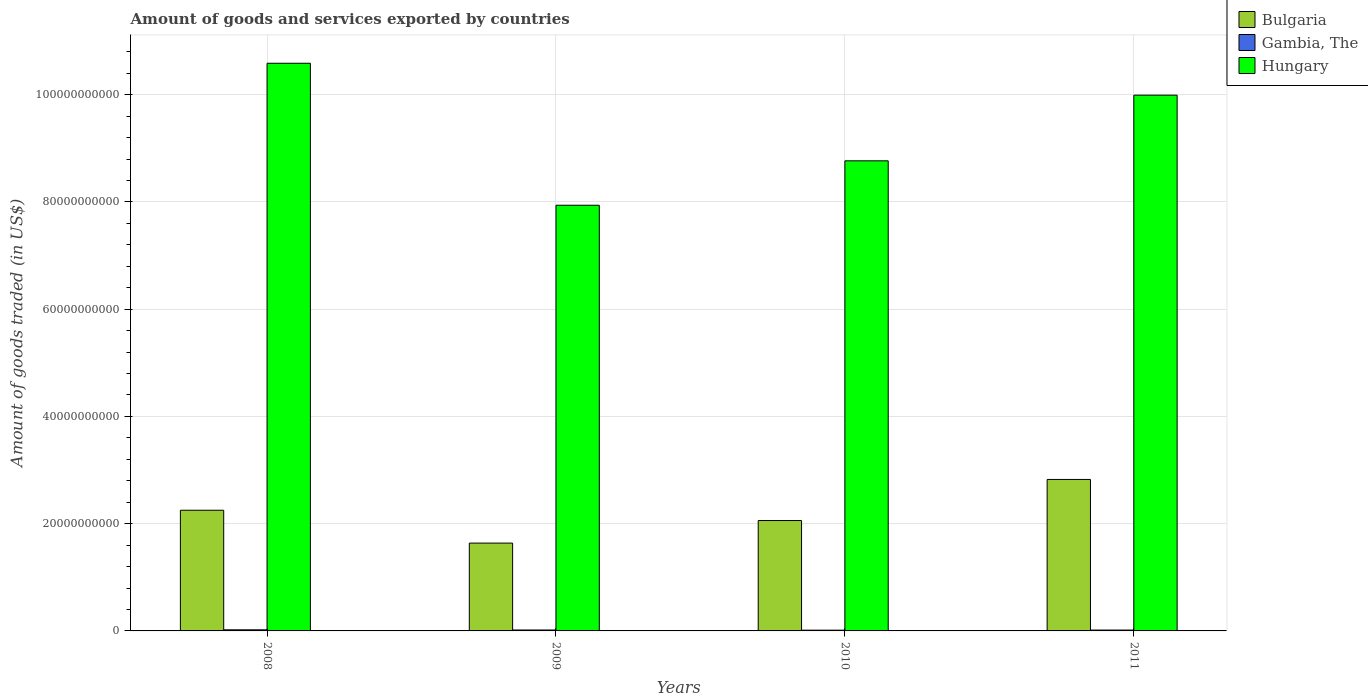How many different coloured bars are there?
Your response must be concise. 3. How many bars are there on the 4th tick from the right?
Offer a very short reply. 3. In how many cases, is the number of bars for a given year not equal to the number of legend labels?
Provide a succinct answer. 0. What is the total amount of goods and services exported in Bulgaria in 2010?
Offer a very short reply. 2.06e+1. Across all years, what is the maximum total amount of goods and services exported in Bulgaria?
Offer a very short reply. 2.82e+1. Across all years, what is the minimum total amount of goods and services exported in Hungary?
Your response must be concise. 7.94e+1. In which year was the total amount of goods and services exported in Hungary maximum?
Your answer should be very brief. 2008. What is the total total amount of goods and services exported in Gambia, The in the graph?
Ensure brevity in your answer.  6.82e+08. What is the difference between the total amount of goods and services exported in Bulgaria in 2010 and that in 2011?
Your answer should be compact. -7.66e+09. What is the difference between the total amount of goods and services exported in Hungary in 2008 and the total amount of goods and services exported in Gambia, The in 2010?
Keep it short and to the point. 1.06e+11. What is the average total amount of goods and services exported in Bulgaria per year?
Your response must be concise. 2.19e+1. In the year 2010, what is the difference between the total amount of goods and services exported in Bulgaria and total amount of goods and services exported in Hungary?
Provide a succinct answer. -6.71e+1. In how many years, is the total amount of goods and services exported in Gambia, The greater than 72000000000 US$?
Give a very brief answer. 0. What is the ratio of the total amount of goods and services exported in Bulgaria in 2009 to that in 2010?
Provide a short and direct response. 0.8. Is the total amount of goods and services exported in Bulgaria in 2009 less than that in 2011?
Your answer should be very brief. Yes. Is the difference between the total amount of goods and services exported in Bulgaria in 2009 and 2011 greater than the difference between the total amount of goods and services exported in Hungary in 2009 and 2011?
Offer a very short reply. Yes. What is the difference between the highest and the second highest total amount of goods and services exported in Hungary?
Keep it short and to the point. 5.95e+09. What is the difference between the highest and the lowest total amount of goods and services exported in Gambia, The?
Provide a succinct answer. 6.56e+07. In how many years, is the total amount of goods and services exported in Hungary greater than the average total amount of goods and services exported in Hungary taken over all years?
Your answer should be very brief. 2. Is the sum of the total amount of goods and services exported in Hungary in 2010 and 2011 greater than the maximum total amount of goods and services exported in Bulgaria across all years?
Keep it short and to the point. Yes. What does the 3rd bar from the left in 2008 represents?
Offer a terse response. Hungary. What does the 2nd bar from the right in 2009 represents?
Make the answer very short. Gambia, The. Is it the case that in every year, the sum of the total amount of goods and services exported in Bulgaria and total amount of goods and services exported in Gambia, The is greater than the total amount of goods and services exported in Hungary?
Your response must be concise. No. Are all the bars in the graph horizontal?
Offer a terse response. No. How many years are there in the graph?
Make the answer very short. 4. Are the values on the major ticks of Y-axis written in scientific E-notation?
Your answer should be compact. No. Does the graph contain any zero values?
Offer a terse response. No. How are the legend labels stacked?
Ensure brevity in your answer.  Vertical. What is the title of the graph?
Your answer should be very brief. Amount of goods and services exported by countries. Does "Sub-Saharan Africa (all income levels)" appear as one of the legend labels in the graph?
Provide a succinct answer. No. What is the label or title of the X-axis?
Ensure brevity in your answer.  Years. What is the label or title of the Y-axis?
Your answer should be compact. Amount of goods traded (in US$). What is the Amount of goods traded (in US$) of Bulgaria in 2008?
Keep it short and to the point. 2.25e+1. What is the Amount of goods traded (in US$) of Gambia, The in 2008?
Provide a short and direct response. 2.06e+08. What is the Amount of goods traded (in US$) of Hungary in 2008?
Your response must be concise. 1.06e+11. What is the Amount of goods traded (in US$) of Bulgaria in 2009?
Your response must be concise. 1.64e+1. What is the Amount of goods traded (in US$) of Gambia, The in 2009?
Your answer should be compact. 1.74e+08. What is the Amount of goods traded (in US$) in Hungary in 2009?
Provide a short and direct response. 7.94e+1. What is the Amount of goods traded (in US$) in Bulgaria in 2010?
Your answer should be very brief. 2.06e+1. What is the Amount of goods traded (in US$) in Gambia, The in 2010?
Offer a very short reply. 1.40e+08. What is the Amount of goods traded (in US$) in Hungary in 2010?
Provide a short and direct response. 8.77e+1. What is the Amount of goods traded (in US$) of Bulgaria in 2011?
Keep it short and to the point. 2.82e+1. What is the Amount of goods traded (in US$) of Gambia, The in 2011?
Your answer should be compact. 1.62e+08. What is the Amount of goods traded (in US$) in Hungary in 2011?
Your answer should be very brief. 9.99e+1. Across all years, what is the maximum Amount of goods traded (in US$) of Bulgaria?
Offer a terse response. 2.82e+1. Across all years, what is the maximum Amount of goods traded (in US$) of Gambia, The?
Make the answer very short. 2.06e+08. Across all years, what is the maximum Amount of goods traded (in US$) of Hungary?
Your answer should be very brief. 1.06e+11. Across all years, what is the minimum Amount of goods traded (in US$) in Bulgaria?
Provide a short and direct response. 1.64e+1. Across all years, what is the minimum Amount of goods traded (in US$) of Gambia, The?
Offer a terse response. 1.40e+08. Across all years, what is the minimum Amount of goods traded (in US$) of Hungary?
Ensure brevity in your answer.  7.94e+1. What is the total Amount of goods traded (in US$) of Bulgaria in the graph?
Provide a short and direct response. 8.77e+1. What is the total Amount of goods traded (in US$) of Gambia, The in the graph?
Offer a terse response. 6.82e+08. What is the total Amount of goods traded (in US$) of Hungary in the graph?
Make the answer very short. 3.73e+11. What is the difference between the Amount of goods traded (in US$) in Bulgaria in 2008 and that in 2009?
Keep it short and to the point. 6.12e+09. What is the difference between the Amount of goods traded (in US$) in Gambia, The in 2008 and that in 2009?
Make the answer very short. 3.13e+07. What is the difference between the Amount of goods traded (in US$) of Hungary in 2008 and that in 2009?
Your answer should be compact. 2.65e+1. What is the difference between the Amount of goods traded (in US$) of Bulgaria in 2008 and that in 2010?
Your answer should be compact. 1.92e+09. What is the difference between the Amount of goods traded (in US$) in Gambia, The in 2008 and that in 2010?
Make the answer very short. 6.56e+07. What is the difference between the Amount of goods traded (in US$) of Hungary in 2008 and that in 2010?
Your answer should be compact. 1.82e+1. What is the difference between the Amount of goods traded (in US$) of Bulgaria in 2008 and that in 2011?
Your answer should be compact. -5.74e+09. What is the difference between the Amount of goods traded (in US$) in Gambia, The in 2008 and that in 2011?
Provide a succinct answer. 4.34e+07. What is the difference between the Amount of goods traded (in US$) in Hungary in 2008 and that in 2011?
Your answer should be compact. 5.95e+09. What is the difference between the Amount of goods traded (in US$) in Bulgaria in 2009 and that in 2010?
Give a very brief answer. -4.20e+09. What is the difference between the Amount of goods traded (in US$) in Gambia, The in 2009 and that in 2010?
Offer a very short reply. 3.43e+07. What is the difference between the Amount of goods traded (in US$) of Hungary in 2009 and that in 2010?
Your answer should be compact. -8.29e+09. What is the difference between the Amount of goods traded (in US$) in Bulgaria in 2009 and that in 2011?
Your response must be concise. -1.19e+1. What is the difference between the Amount of goods traded (in US$) in Gambia, The in 2009 and that in 2011?
Offer a terse response. 1.21e+07. What is the difference between the Amount of goods traded (in US$) of Hungary in 2009 and that in 2011?
Keep it short and to the point. -2.05e+1. What is the difference between the Amount of goods traded (in US$) of Bulgaria in 2010 and that in 2011?
Ensure brevity in your answer.  -7.66e+09. What is the difference between the Amount of goods traded (in US$) in Gambia, The in 2010 and that in 2011?
Keep it short and to the point. -2.22e+07. What is the difference between the Amount of goods traded (in US$) of Hungary in 2010 and that in 2011?
Offer a very short reply. -1.22e+1. What is the difference between the Amount of goods traded (in US$) of Bulgaria in 2008 and the Amount of goods traded (in US$) of Gambia, The in 2009?
Your response must be concise. 2.23e+1. What is the difference between the Amount of goods traded (in US$) of Bulgaria in 2008 and the Amount of goods traded (in US$) of Hungary in 2009?
Make the answer very short. -5.69e+1. What is the difference between the Amount of goods traded (in US$) of Gambia, The in 2008 and the Amount of goods traded (in US$) of Hungary in 2009?
Your response must be concise. -7.92e+1. What is the difference between the Amount of goods traded (in US$) of Bulgaria in 2008 and the Amount of goods traded (in US$) of Gambia, The in 2010?
Ensure brevity in your answer.  2.24e+1. What is the difference between the Amount of goods traded (in US$) in Bulgaria in 2008 and the Amount of goods traded (in US$) in Hungary in 2010?
Your answer should be very brief. -6.52e+1. What is the difference between the Amount of goods traded (in US$) in Gambia, The in 2008 and the Amount of goods traded (in US$) in Hungary in 2010?
Provide a succinct answer. -8.75e+1. What is the difference between the Amount of goods traded (in US$) in Bulgaria in 2008 and the Amount of goods traded (in US$) in Gambia, The in 2011?
Keep it short and to the point. 2.23e+1. What is the difference between the Amount of goods traded (in US$) in Bulgaria in 2008 and the Amount of goods traded (in US$) in Hungary in 2011?
Your response must be concise. -7.74e+1. What is the difference between the Amount of goods traded (in US$) in Gambia, The in 2008 and the Amount of goods traded (in US$) in Hungary in 2011?
Make the answer very short. -9.97e+1. What is the difference between the Amount of goods traded (in US$) in Bulgaria in 2009 and the Amount of goods traded (in US$) in Gambia, The in 2010?
Your answer should be compact. 1.62e+1. What is the difference between the Amount of goods traded (in US$) in Bulgaria in 2009 and the Amount of goods traded (in US$) in Hungary in 2010?
Give a very brief answer. -7.13e+1. What is the difference between the Amount of goods traded (in US$) of Gambia, The in 2009 and the Amount of goods traded (in US$) of Hungary in 2010?
Provide a short and direct response. -8.75e+1. What is the difference between the Amount of goods traded (in US$) in Bulgaria in 2009 and the Amount of goods traded (in US$) in Gambia, The in 2011?
Offer a terse response. 1.62e+1. What is the difference between the Amount of goods traded (in US$) of Bulgaria in 2009 and the Amount of goods traded (in US$) of Hungary in 2011?
Your response must be concise. -8.35e+1. What is the difference between the Amount of goods traded (in US$) in Gambia, The in 2009 and the Amount of goods traded (in US$) in Hungary in 2011?
Give a very brief answer. -9.97e+1. What is the difference between the Amount of goods traded (in US$) in Bulgaria in 2010 and the Amount of goods traded (in US$) in Gambia, The in 2011?
Make the answer very short. 2.04e+1. What is the difference between the Amount of goods traded (in US$) of Bulgaria in 2010 and the Amount of goods traded (in US$) of Hungary in 2011?
Your answer should be very brief. -7.93e+1. What is the difference between the Amount of goods traded (in US$) in Gambia, The in 2010 and the Amount of goods traded (in US$) in Hungary in 2011?
Your answer should be very brief. -9.98e+1. What is the average Amount of goods traded (in US$) in Bulgaria per year?
Offer a very short reply. 2.19e+1. What is the average Amount of goods traded (in US$) in Gambia, The per year?
Give a very brief answer. 1.70e+08. What is the average Amount of goods traded (in US$) in Hungary per year?
Your response must be concise. 9.32e+1. In the year 2008, what is the difference between the Amount of goods traded (in US$) in Bulgaria and Amount of goods traded (in US$) in Gambia, The?
Your answer should be very brief. 2.23e+1. In the year 2008, what is the difference between the Amount of goods traded (in US$) in Bulgaria and Amount of goods traded (in US$) in Hungary?
Offer a very short reply. -8.34e+1. In the year 2008, what is the difference between the Amount of goods traded (in US$) of Gambia, The and Amount of goods traded (in US$) of Hungary?
Your answer should be compact. -1.06e+11. In the year 2009, what is the difference between the Amount of goods traded (in US$) in Bulgaria and Amount of goods traded (in US$) in Gambia, The?
Keep it short and to the point. 1.62e+1. In the year 2009, what is the difference between the Amount of goods traded (in US$) in Bulgaria and Amount of goods traded (in US$) in Hungary?
Keep it short and to the point. -6.30e+1. In the year 2009, what is the difference between the Amount of goods traded (in US$) of Gambia, The and Amount of goods traded (in US$) of Hungary?
Give a very brief answer. -7.92e+1. In the year 2010, what is the difference between the Amount of goods traded (in US$) in Bulgaria and Amount of goods traded (in US$) in Gambia, The?
Ensure brevity in your answer.  2.04e+1. In the year 2010, what is the difference between the Amount of goods traded (in US$) in Bulgaria and Amount of goods traded (in US$) in Hungary?
Offer a very short reply. -6.71e+1. In the year 2010, what is the difference between the Amount of goods traded (in US$) of Gambia, The and Amount of goods traded (in US$) of Hungary?
Make the answer very short. -8.75e+1. In the year 2011, what is the difference between the Amount of goods traded (in US$) of Bulgaria and Amount of goods traded (in US$) of Gambia, The?
Provide a succinct answer. 2.81e+1. In the year 2011, what is the difference between the Amount of goods traded (in US$) in Bulgaria and Amount of goods traded (in US$) in Hungary?
Make the answer very short. -7.17e+1. In the year 2011, what is the difference between the Amount of goods traded (in US$) of Gambia, The and Amount of goods traded (in US$) of Hungary?
Your response must be concise. -9.97e+1. What is the ratio of the Amount of goods traded (in US$) in Bulgaria in 2008 to that in 2009?
Give a very brief answer. 1.37. What is the ratio of the Amount of goods traded (in US$) of Gambia, The in 2008 to that in 2009?
Offer a very short reply. 1.18. What is the ratio of the Amount of goods traded (in US$) of Hungary in 2008 to that in 2009?
Ensure brevity in your answer.  1.33. What is the ratio of the Amount of goods traded (in US$) of Bulgaria in 2008 to that in 2010?
Offer a very short reply. 1.09. What is the ratio of the Amount of goods traded (in US$) in Gambia, The in 2008 to that in 2010?
Keep it short and to the point. 1.47. What is the ratio of the Amount of goods traded (in US$) in Hungary in 2008 to that in 2010?
Make the answer very short. 1.21. What is the ratio of the Amount of goods traded (in US$) in Bulgaria in 2008 to that in 2011?
Keep it short and to the point. 0.8. What is the ratio of the Amount of goods traded (in US$) in Gambia, The in 2008 to that in 2011?
Offer a very short reply. 1.27. What is the ratio of the Amount of goods traded (in US$) in Hungary in 2008 to that in 2011?
Ensure brevity in your answer.  1.06. What is the ratio of the Amount of goods traded (in US$) of Bulgaria in 2009 to that in 2010?
Offer a very short reply. 0.8. What is the ratio of the Amount of goods traded (in US$) in Gambia, The in 2009 to that in 2010?
Offer a terse response. 1.25. What is the ratio of the Amount of goods traded (in US$) in Hungary in 2009 to that in 2010?
Offer a very short reply. 0.91. What is the ratio of the Amount of goods traded (in US$) in Bulgaria in 2009 to that in 2011?
Your response must be concise. 0.58. What is the ratio of the Amount of goods traded (in US$) of Gambia, The in 2009 to that in 2011?
Offer a terse response. 1.07. What is the ratio of the Amount of goods traded (in US$) in Hungary in 2009 to that in 2011?
Offer a terse response. 0.79. What is the ratio of the Amount of goods traded (in US$) in Bulgaria in 2010 to that in 2011?
Your response must be concise. 0.73. What is the ratio of the Amount of goods traded (in US$) of Gambia, The in 2010 to that in 2011?
Your answer should be very brief. 0.86. What is the ratio of the Amount of goods traded (in US$) in Hungary in 2010 to that in 2011?
Give a very brief answer. 0.88. What is the difference between the highest and the second highest Amount of goods traded (in US$) of Bulgaria?
Offer a very short reply. 5.74e+09. What is the difference between the highest and the second highest Amount of goods traded (in US$) of Gambia, The?
Make the answer very short. 3.13e+07. What is the difference between the highest and the second highest Amount of goods traded (in US$) of Hungary?
Offer a very short reply. 5.95e+09. What is the difference between the highest and the lowest Amount of goods traded (in US$) in Bulgaria?
Offer a terse response. 1.19e+1. What is the difference between the highest and the lowest Amount of goods traded (in US$) of Gambia, The?
Provide a short and direct response. 6.56e+07. What is the difference between the highest and the lowest Amount of goods traded (in US$) of Hungary?
Your answer should be compact. 2.65e+1. 